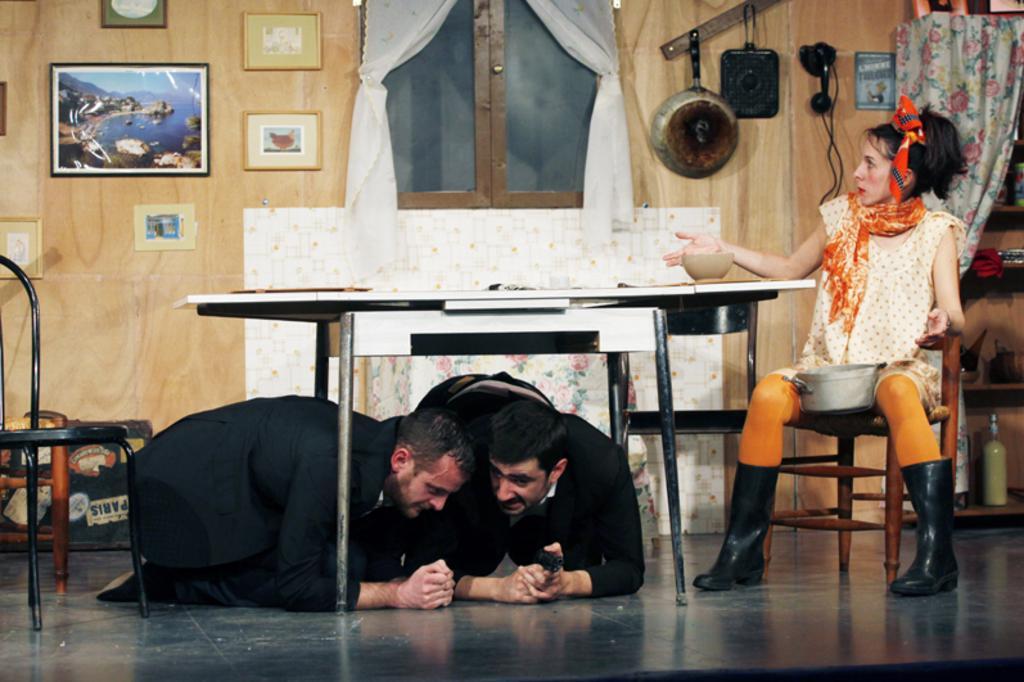Describe this image in one or two sentences. In this picture we can see two people on the floor, one woman is sitting on a chair, here we can see a table, chairs, bottle, shelves and some objects and in the background we can see a wall, photo frames, curtains, cupboard, telephone and some objects. 